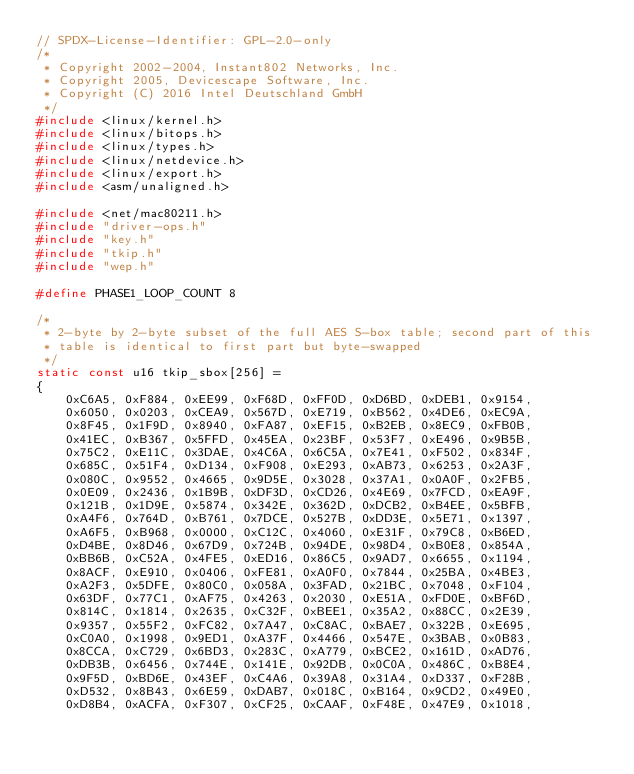<code> <loc_0><loc_0><loc_500><loc_500><_C_>// SPDX-License-Identifier: GPL-2.0-only
/*
 * Copyright 2002-2004, Instant802 Networks, Inc.
 * Copyright 2005, Devicescape Software, Inc.
 * Copyright (C) 2016 Intel Deutschland GmbH
 */
#include <linux/kernel.h>
#include <linux/bitops.h>
#include <linux/types.h>
#include <linux/netdevice.h>
#include <linux/export.h>
#include <asm/unaligned.h>

#include <net/mac80211.h>
#include "driver-ops.h"
#include "key.h"
#include "tkip.h"
#include "wep.h"

#define PHASE1_LOOP_COUNT 8

/*
 * 2-byte by 2-byte subset of the full AES S-box table; second part of this
 * table is identical to first part but byte-swapped
 */
static const u16 tkip_sbox[256] =
{
	0xC6A5, 0xF884, 0xEE99, 0xF68D, 0xFF0D, 0xD6BD, 0xDEB1, 0x9154,
	0x6050, 0x0203, 0xCEA9, 0x567D, 0xE719, 0xB562, 0x4DE6, 0xEC9A,
	0x8F45, 0x1F9D, 0x8940, 0xFA87, 0xEF15, 0xB2EB, 0x8EC9, 0xFB0B,
	0x41EC, 0xB367, 0x5FFD, 0x45EA, 0x23BF, 0x53F7, 0xE496, 0x9B5B,
	0x75C2, 0xE11C, 0x3DAE, 0x4C6A, 0x6C5A, 0x7E41, 0xF502, 0x834F,
	0x685C, 0x51F4, 0xD134, 0xF908, 0xE293, 0xAB73, 0x6253, 0x2A3F,
	0x080C, 0x9552, 0x4665, 0x9D5E, 0x3028, 0x37A1, 0x0A0F, 0x2FB5,
	0x0E09, 0x2436, 0x1B9B, 0xDF3D, 0xCD26, 0x4E69, 0x7FCD, 0xEA9F,
	0x121B, 0x1D9E, 0x5874, 0x342E, 0x362D, 0xDCB2, 0xB4EE, 0x5BFB,
	0xA4F6, 0x764D, 0xB761, 0x7DCE, 0x527B, 0xDD3E, 0x5E71, 0x1397,
	0xA6F5, 0xB968, 0x0000, 0xC12C, 0x4060, 0xE31F, 0x79C8, 0xB6ED,
	0xD4BE, 0x8D46, 0x67D9, 0x724B, 0x94DE, 0x98D4, 0xB0E8, 0x854A,
	0xBB6B, 0xC52A, 0x4FE5, 0xED16, 0x86C5, 0x9AD7, 0x6655, 0x1194,
	0x8ACF, 0xE910, 0x0406, 0xFE81, 0xA0F0, 0x7844, 0x25BA, 0x4BE3,
	0xA2F3, 0x5DFE, 0x80C0, 0x058A, 0x3FAD, 0x21BC, 0x7048, 0xF104,
	0x63DF, 0x77C1, 0xAF75, 0x4263, 0x2030, 0xE51A, 0xFD0E, 0xBF6D,
	0x814C, 0x1814, 0x2635, 0xC32F, 0xBEE1, 0x35A2, 0x88CC, 0x2E39,
	0x9357, 0x55F2, 0xFC82, 0x7A47, 0xC8AC, 0xBAE7, 0x322B, 0xE695,
	0xC0A0, 0x1998, 0x9ED1, 0xA37F, 0x4466, 0x547E, 0x3BAB, 0x0B83,
	0x8CCA, 0xC729, 0x6BD3, 0x283C, 0xA779, 0xBCE2, 0x161D, 0xAD76,
	0xDB3B, 0x6456, 0x744E, 0x141E, 0x92DB, 0x0C0A, 0x486C, 0xB8E4,
	0x9F5D, 0xBD6E, 0x43EF, 0xC4A6, 0x39A8, 0x31A4, 0xD337, 0xF28B,
	0xD532, 0x8B43, 0x6E59, 0xDAB7, 0x018C, 0xB164, 0x9CD2, 0x49E0,
	0xD8B4, 0xACFA, 0xF307, 0xCF25, 0xCAAF, 0xF48E, 0x47E9, 0x1018,</code> 